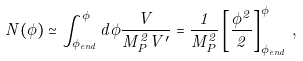<formula> <loc_0><loc_0><loc_500><loc_500>N ( \phi ) \simeq \int _ { \phi _ { e n d } } ^ { \phi } d \phi \frac { V } { M _ { P } ^ { 2 } V ^ { \prime } } = \frac { 1 } { M _ { P } ^ { 2 } } \left [ \frac { \phi ^ { 2 } } { 2 } \right ] _ { \phi _ { e n d } } ^ { \phi } \, ,</formula> 